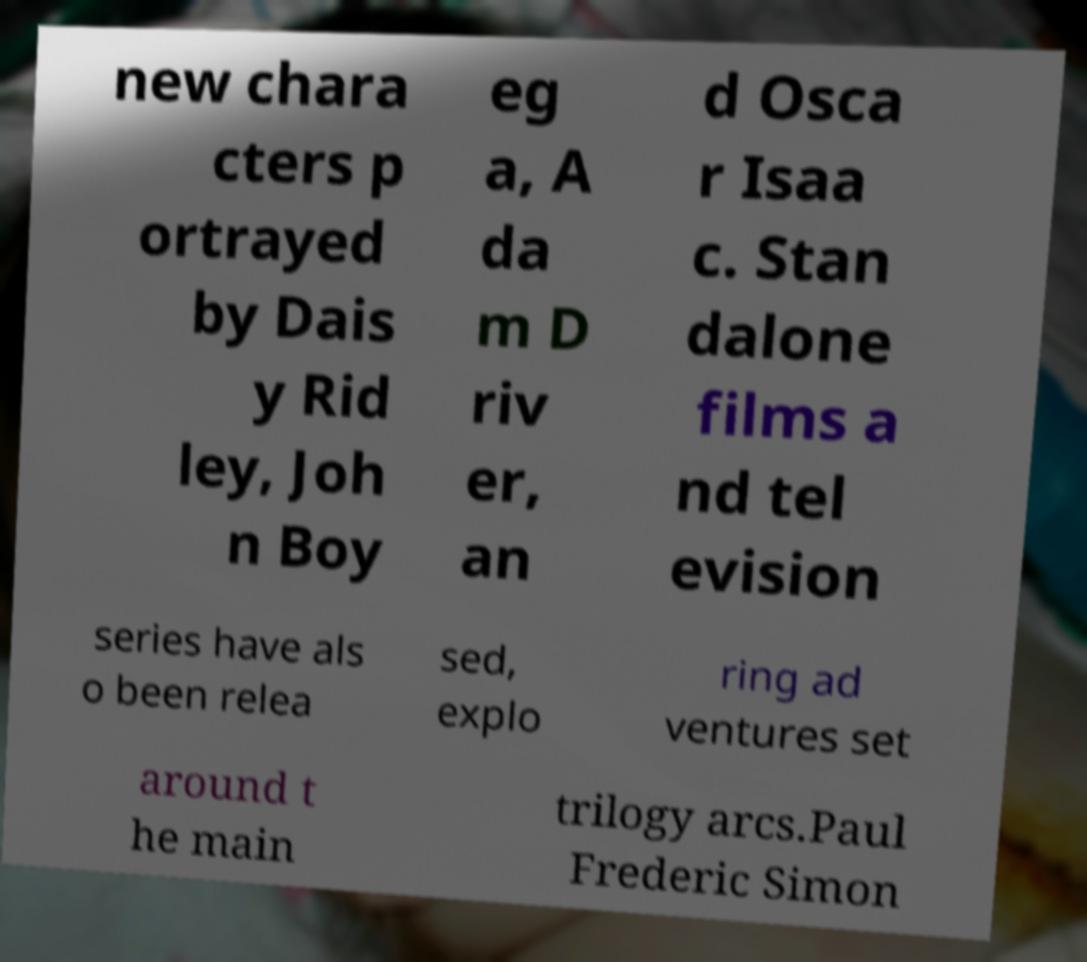I need the written content from this picture converted into text. Can you do that? new chara cters p ortrayed by Dais y Rid ley, Joh n Boy eg a, A da m D riv er, an d Osca r Isaa c. Stan dalone films a nd tel evision series have als o been relea sed, explo ring ad ventures set around t he main trilogy arcs.Paul Frederic Simon 